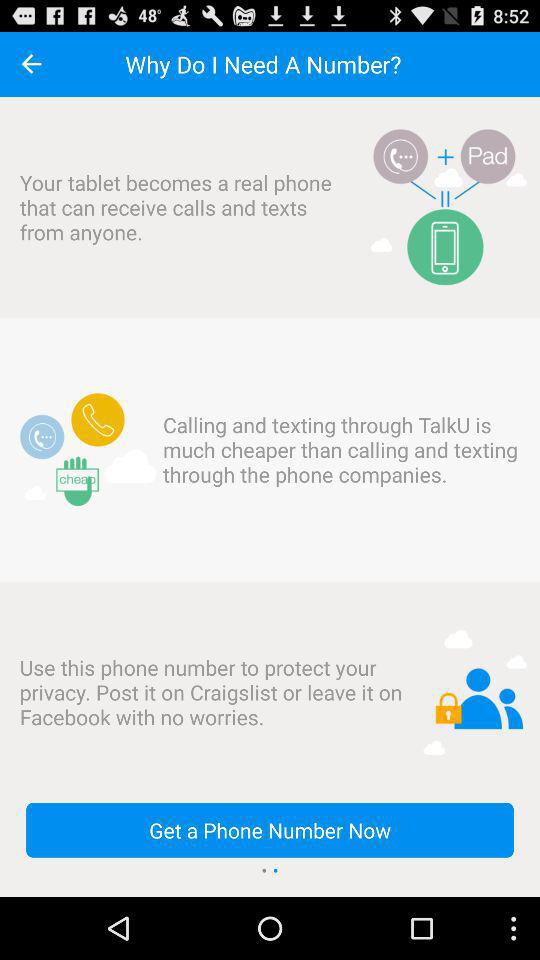What is the advantage of using "TalkU"? The advantage of using "TalkU" is that calling and texting through it are much cheaper than calling and texting through the phone companies. 